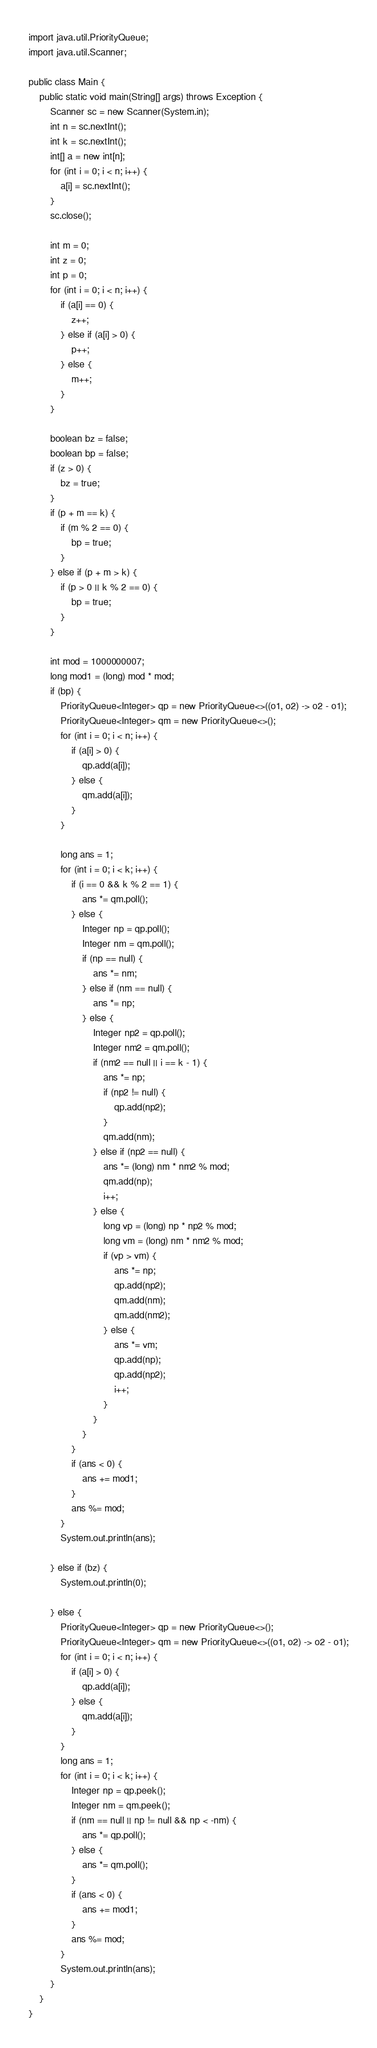Convert code to text. <code><loc_0><loc_0><loc_500><loc_500><_Java_>import java.util.PriorityQueue;
import java.util.Scanner;

public class Main {
	public static void main(String[] args) throws Exception {
		Scanner sc = new Scanner(System.in);
		int n = sc.nextInt();
		int k = sc.nextInt();
		int[] a = new int[n];
		for (int i = 0; i < n; i++) {
			a[i] = sc.nextInt();
		}
		sc.close();

		int m = 0;
		int z = 0;
		int p = 0;
		for (int i = 0; i < n; i++) {
			if (a[i] == 0) {
				z++;
			} else if (a[i] > 0) {
				p++;
			} else {
				m++;
			}
		}

		boolean bz = false;
		boolean bp = false;
		if (z > 0) {
			bz = true;
		}
		if (p + m == k) {
			if (m % 2 == 0) {
				bp = true;
			}
		} else if (p + m > k) {
			if (p > 0 || k % 2 == 0) {
				bp = true;
			}
		}

		int mod = 1000000007;
		long mod1 = (long) mod * mod;
		if (bp) {
			PriorityQueue<Integer> qp = new PriorityQueue<>((o1, o2) -> o2 - o1);
			PriorityQueue<Integer> qm = new PriorityQueue<>();
			for (int i = 0; i < n; i++) {
				if (a[i] > 0) {
					qp.add(a[i]);
				} else {
					qm.add(a[i]);
				}
			}

			long ans = 1;
			for (int i = 0; i < k; i++) {
				if (i == 0 && k % 2 == 1) {
					ans *= qm.poll();
				} else {
					Integer np = qp.poll();
					Integer nm = qm.poll();
					if (np == null) {
						ans *= nm;
					} else if (nm == null) {
						ans *= np;
					} else {
						Integer np2 = qp.poll();
						Integer nm2 = qm.poll();
						if (nm2 == null || i == k - 1) {
							ans *= np;
							if (np2 != null) {
								qp.add(np2);
							}
							qm.add(nm);
						} else if (np2 == null) {
							ans *= (long) nm * nm2 % mod;
							qm.add(np);
							i++;
						} else {
							long vp = (long) np * np2 % mod;
							long vm = (long) nm * nm2 % mod;
							if (vp > vm) {
								ans *= np;
								qp.add(np2);
								qm.add(nm);
								qm.add(nm2);
							} else {
								ans *= vm;
								qp.add(np);
								qp.add(np2);
								i++;
							}
						}
					}
				}
				if (ans < 0) {
					ans += mod1;
				}
				ans %= mod;
			}
			System.out.println(ans);

		} else if (bz) {
			System.out.println(0);

		} else {
			PriorityQueue<Integer> qp = new PriorityQueue<>();
			PriorityQueue<Integer> qm = new PriorityQueue<>((o1, o2) -> o2 - o1);
			for (int i = 0; i < n; i++) {
				if (a[i] > 0) {
					qp.add(a[i]);
				} else {
					qm.add(a[i]);
				}
			}
			long ans = 1;
			for (int i = 0; i < k; i++) {
				Integer np = qp.peek();
				Integer nm = qm.peek();
				if (nm == null || np != null && np < -nm) {
					ans *= qp.poll();
				} else {
					ans *= qm.poll();
				}
				if (ans < 0) {
					ans += mod1;
				}
				ans %= mod;
			}
			System.out.println(ans);
		}
	}
}
</code> 